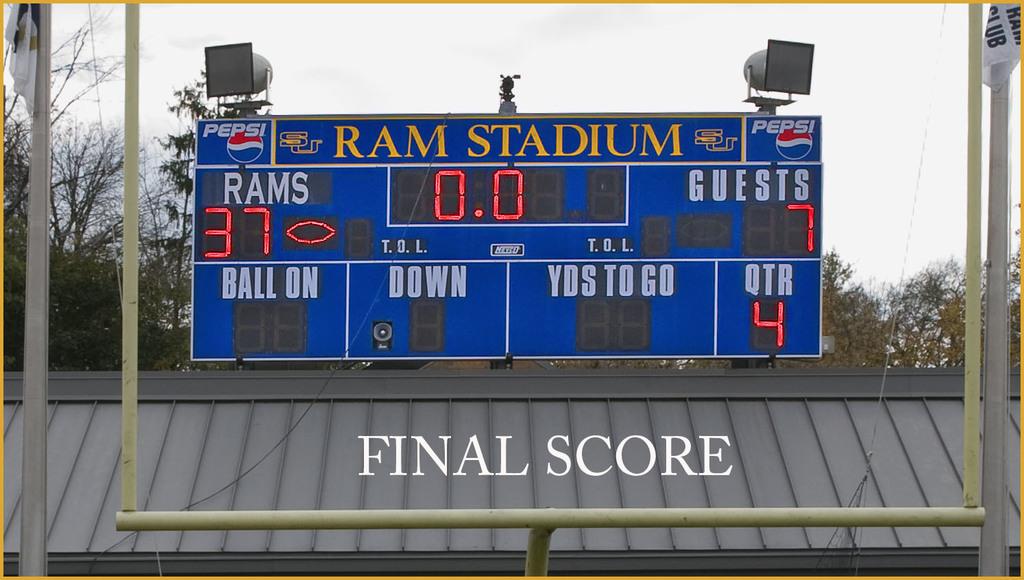What is the score of the game?
Offer a terse response. 37-7. What is the name of the stadium?
Ensure brevity in your answer.  Ram stadium. 